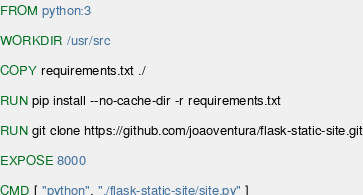<code> <loc_0><loc_0><loc_500><loc_500><_Dockerfile_>FROM python:3

WORKDIR /usr/src

COPY requirements.txt ./

RUN pip install --no-cache-dir -r requirements.txt 

RUN git clone https://github.com/joaoventura/flask-static-site.git

EXPOSE 8000

CMD [ "python", "./flask-static-site/site.py" ]</code> 